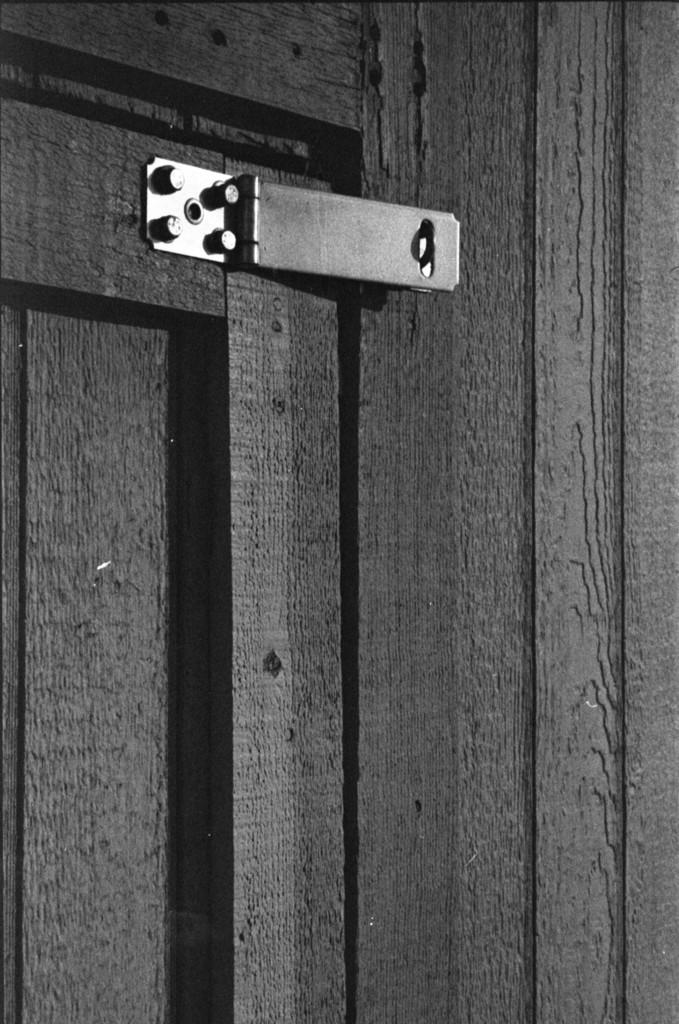What color is the door in the image? The door in the image is black. What material is the wall in the image made of? The wall in the image is made of wood. Where is the hook located in the image? The hook is at the top of the image. What type of liquid is dripping from the structure in the image? There is no structure or liquid present in the image; it only features a black door and a wooden wall. How many hens can be seen in the image? There are no hens present in the image. 